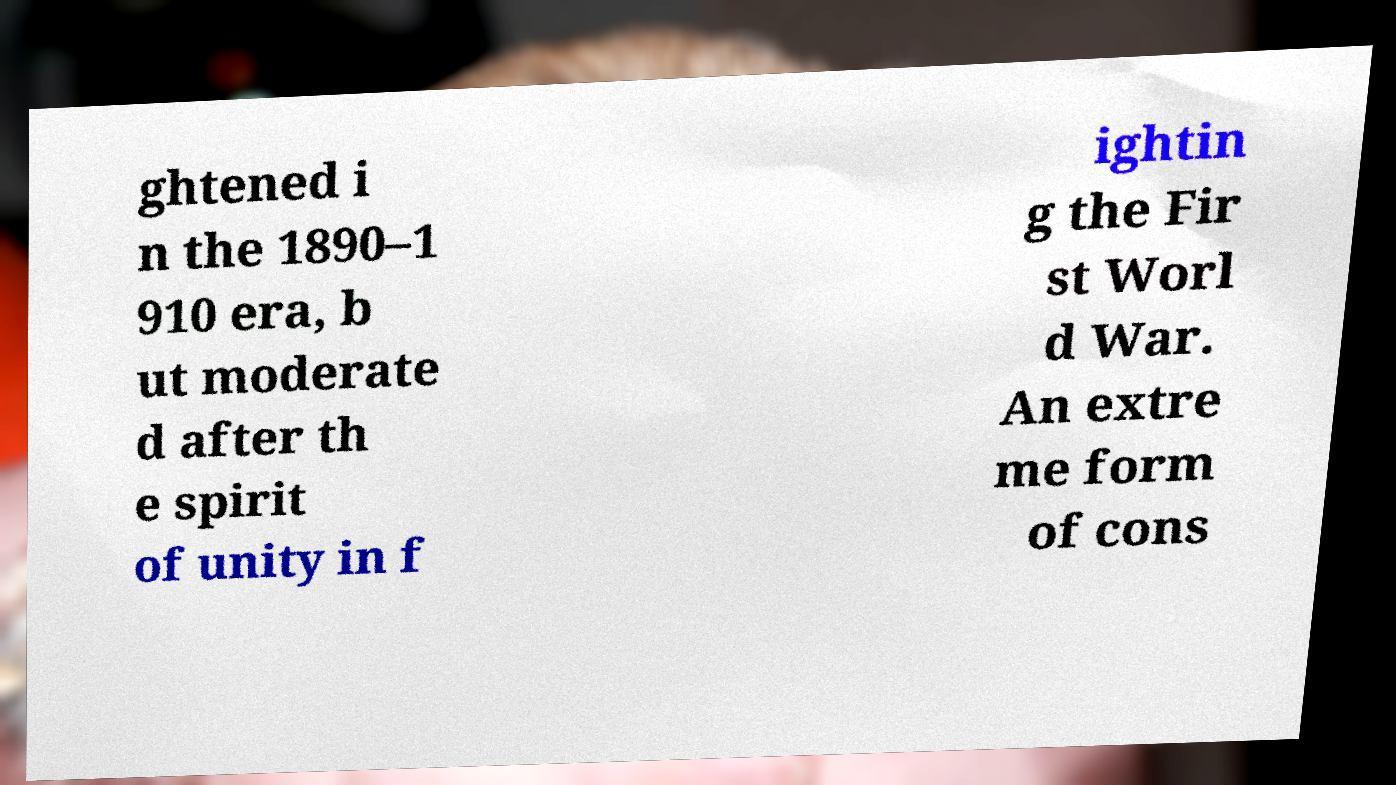For documentation purposes, I need the text within this image transcribed. Could you provide that? ghtened i n the 1890–1 910 era, b ut moderate d after th e spirit of unity in f ightin g the Fir st Worl d War. An extre me form of cons 